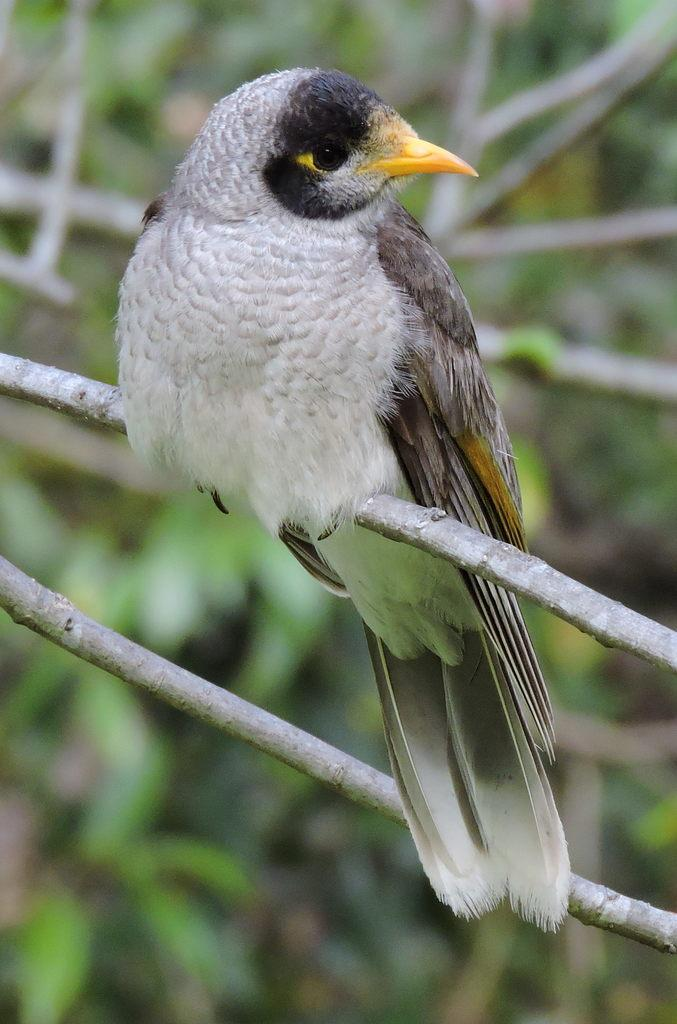What type of animal can be seen in the image? There is a bird in the image. Where is the bird located? The bird is standing on a tree. What colors can be observed on the bird? The bird is white and brown in color. What can be seen in the background of the image? There are trees in the background of the image. What type of record is the bird holding in its toes in the image? There is no record or toes visible in the image; the bird is standing on a tree branch. 